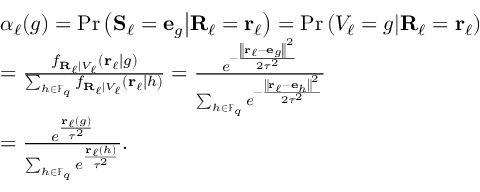<formula> <loc_0><loc_0><loc_500><loc_500>\begin{array} { r l } & { \alpha _ { \ell } ( g ) = P r \left ( { S } _ { \ell } = { e } _ { g } | d l e | { R } _ { \ell } = { r } _ { \ell } \right ) = P r \left ( V _ { \ell } = g | d l e | { R } _ { \ell } = { r } _ { \ell } \right ) } \\ & { = \frac { f _ { { R } _ { \ell } | V _ { \ell } } \left ( { r } _ { \ell } | g \right ) } { \sum _ { h \in \mathbb { F } _ { q } } f _ { { R } _ { \ell } | V _ { \ell } } \left ( { r } _ { \ell } | h \right ) } = \frac { e ^ { - \frac { \left \| { r } _ { \ell } - { e } _ { g } \right \| ^ { 2 } } { 2 \tau ^ { 2 } } } } { \sum _ { h \in \mathbb { F } _ { q } } e ^ { - \frac { \left \| { r } _ { \ell } - { e } _ { h } \right \| ^ { 2 } } { 2 \tau ^ { 2 } } } } } \\ & { = \frac { e ^ { \frac { { r } _ { \ell } ( g ) } { \tau ^ { 2 } } } } { \sum _ { h \in \mathbb { F } _ { q } } e ^ { \frac { { r } _ { \ell } ( h ) } { \tau ^ { 2 } } } } . } \end{array}</formula> 